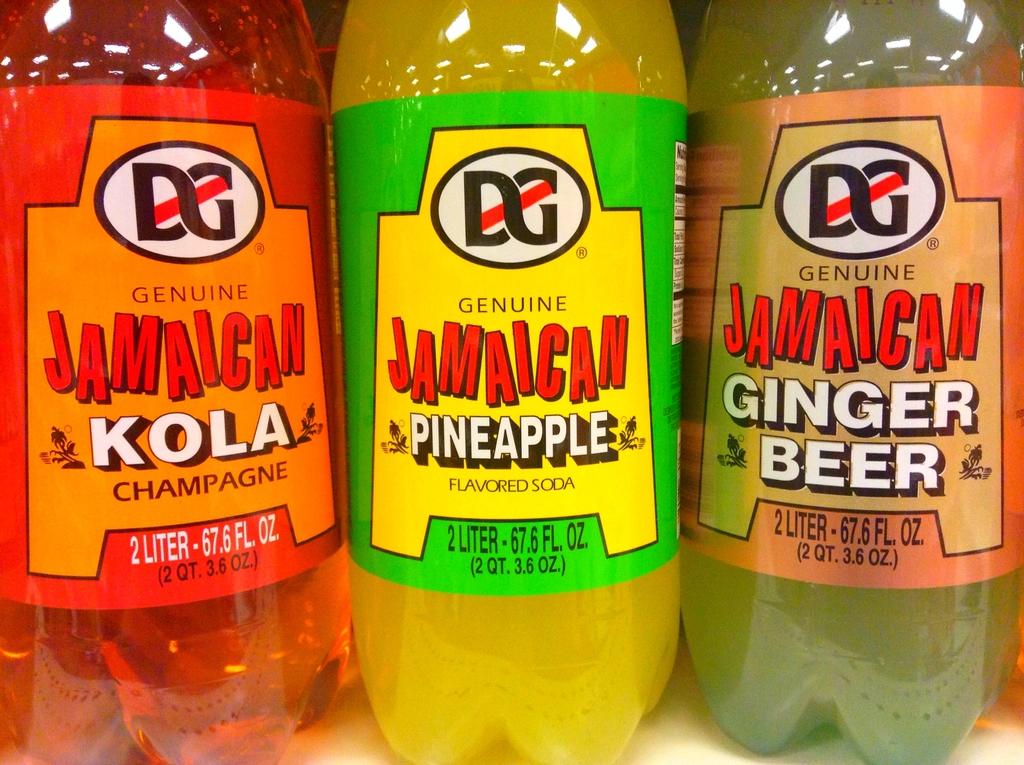How many liters are these bottles?
Keep it short and to the point. 2. Is there a ginger beer here?
Offer a very short reply. Yes. 